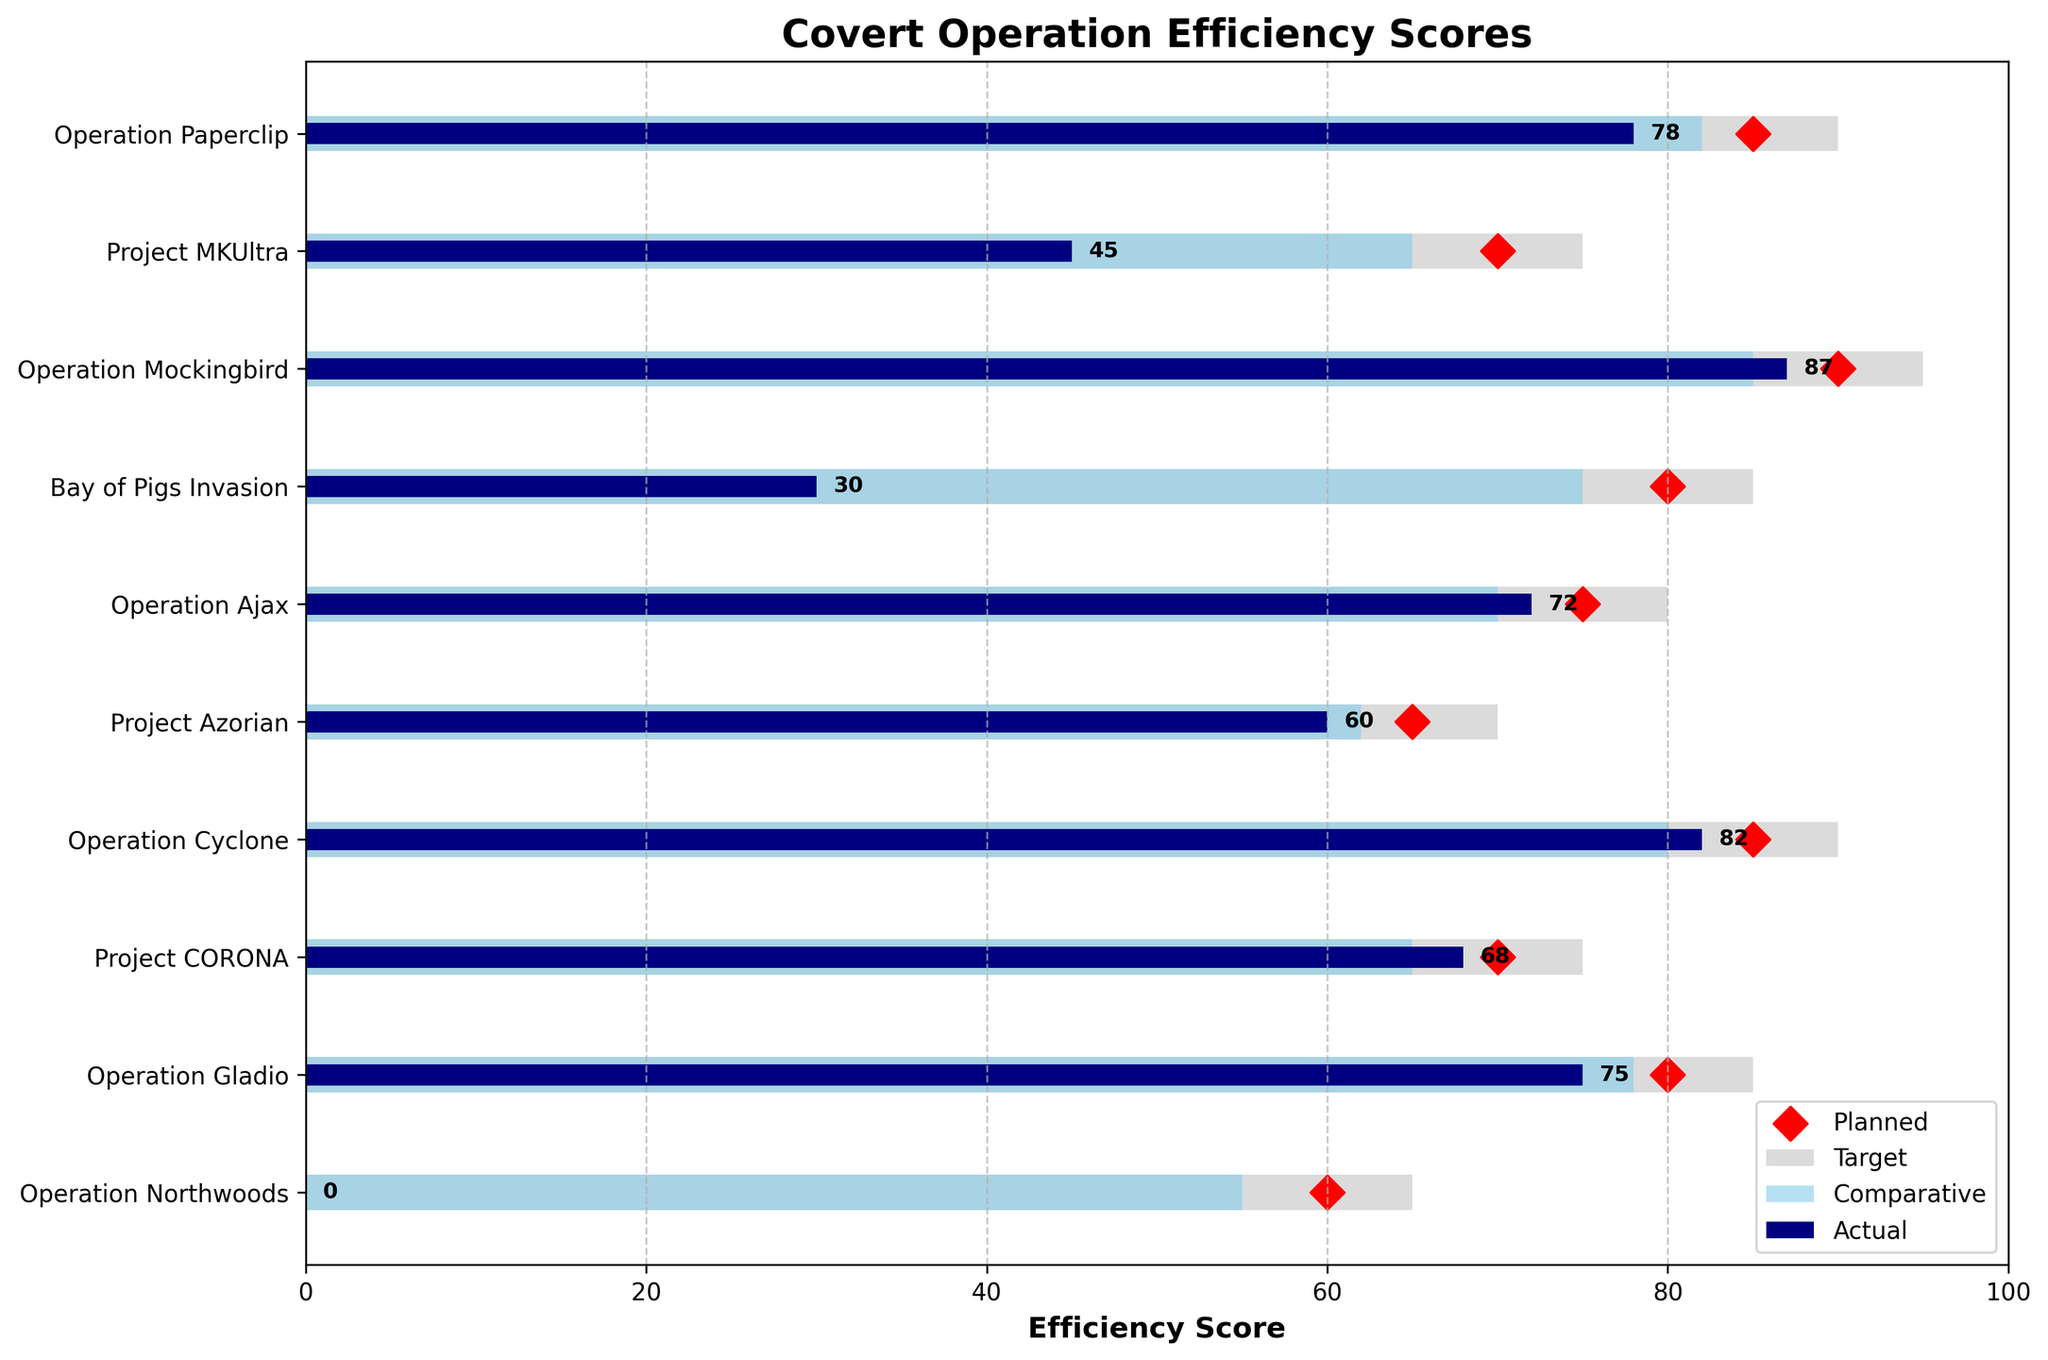What is the title of the figure? The title is found at the top of the chart, providing a concise description of what the figure represents.
Answer: Covert Operation Efficiency Scores How many operations are depicted in the chart? Count the number of operations listed on the y-axis.
Answer: 10 Which operation has the highest Actual Efficiency score? Look for the darkest (navy) bar that extends the furthest to the right. Invert the y-axis to read the operation name.
Answer: Operation Mockingbird How does the Actual Efficiency score of Project MKUltra compare to its Planned Objective score? Find Project MKUltra on the y-axis. Compare the length of the darkest bar (Actual Efficiency) to the red diamond marker (Planned Objective) on its row.
Answer: The Actual Efficiency score is significantly lower than the Planned Objective (45 vs. 70) Which operation has an Actual Efficiency score that matches or exceeds the Comparative Efficiency score? Identify rows where the darkest bar (Actual Efficiency) either matches or extends beyond the middle bar (Comparative Efficiency).
Answer: None What is the average Actual Efficiency score for all operations? Add up all the Actual Efficiency scores and divide by the number of operations: (78 + 45 + 87 + 30 + 72 + 60 + 82 + 68 + 75 + 0) / 10.
Answer: 59.7 Which operation shows the greatest discrepancy between Planned Objective and Actual Efficiency? For each operation, calculate the absolute difference between Planned Objective (red diamond) and Actual Efficiency (darkest bar). Identify the operation with the highest difference.
Answer: Bay of Pigs Invasion How does the Actual Efficiency of Operation Cyclone compare to its Target Efficiency? For Operation Cyclone, compare the lengths of the darkest bar (Actual Efficiency) and the lightest bar (Target Efficiency).
Answer: The Actual Efficiency (82) is less than the Target Efficiency (90) Which operation has an Actual Efficiency score of zero? Look for the row where the darkest bar (Actual Efficiency) has no visible length.
Answer: Operation Northwoods What is the median Comparative Efficiency score across all operations? Order the Comparative Efficiency scores: (55, 62, 65, 65, 70, 75, 78, 80, 82, 85). The median is the average of the two middle values in this ordered list.
Answer: 72.5 